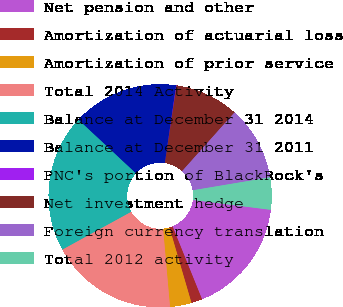<chart> <loc_0><loc_0><loc_500><loc_500><pie_chart><fcel>Net pension and other<fcel>Amortization of actuarial loss<fcel>Amortization of prior service<fcel>Total 2014 Activity<fcel>Balance at December 31 2014<fcel>Balance at December 31 2011<fcel>PNC's portion of BlackRock's<fcel>Net investment hedge<fcel>Foreign currency translation<fcel>Total 2012 activity<nl><fcel>16.88%<fcel>1.59%<fcel>3.12%<fcel>18.41%<fcel>19.94%<fcel>15.35%<fcel>0.06%<fcel>9.24%<fcel>10.76%<fcel>4.65%<nl></chart> 